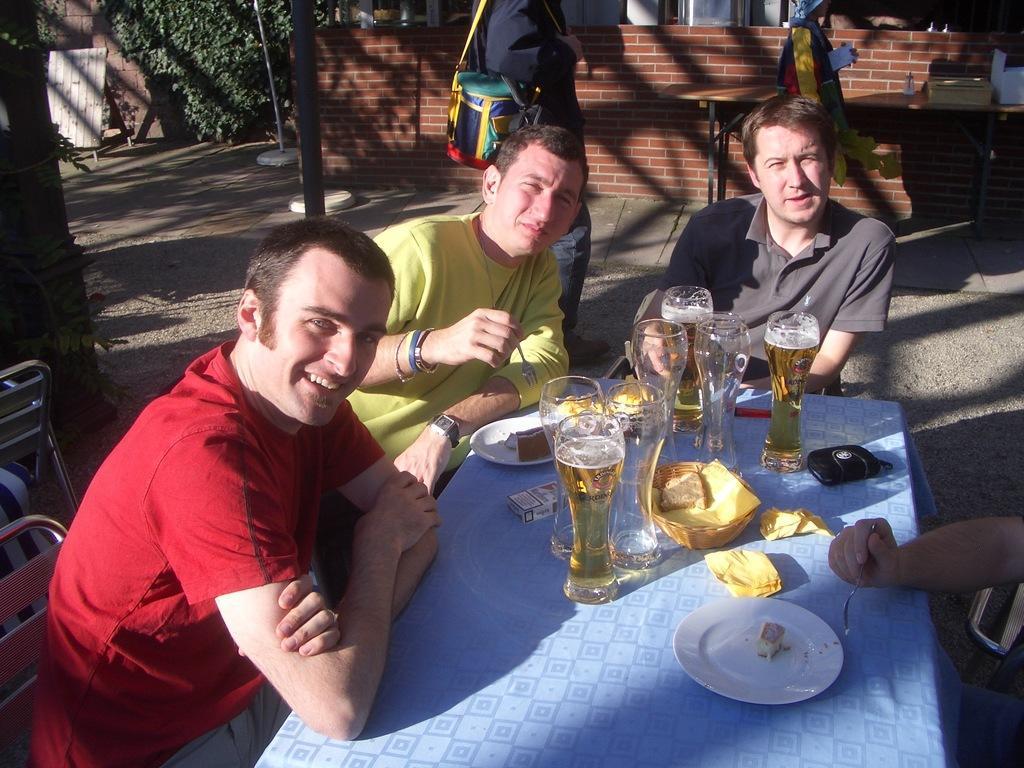In one or two sentences, can you explain what this image depicts? Here we can see a group of people are sitting on the chair and in front here is the table and glasses and some objects on it, and her a person is standing on the road, and here is the wall, and here is the tree. 